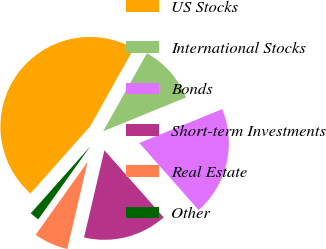Convert chart to OTSL. <chart><loc_0><loc_0><loc_500><loc_500><pie_chart><fcel>US Stocks<fcel>International Stocks<fcel>Bonds<fcel>Short-term Investments<fcel>Real Estate<fcel>Other<nl><fcel>46.57%<fcel>10.69%<fcel>19.65%<fcel>15.17%<fcel>6.2%<fcel>1.72%<nl></chart> 